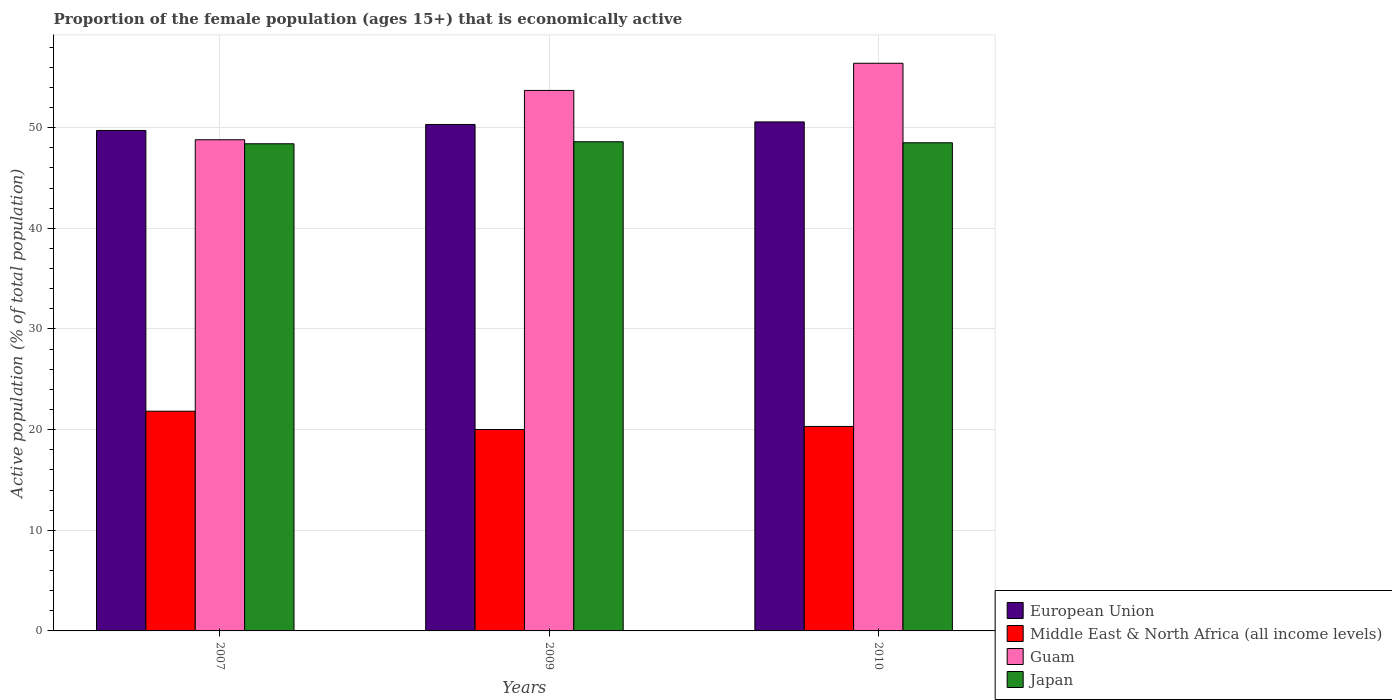How many groups of bars are there?
Ensure brevity in your answer.  3. How many bars are there on the 2nd tick from the left?
Give a very brief answer. 4. In how many cases, is the number of bars for a given year not equal to the number of legend labels?
Your answer should be compact. 0. What is the proportion of the female population that is economically active in Japan in 2007?
Offer a terse response. 48.4. Across all years, what is the maximum proportion of the female population that is economically active in Middle East & North Africa (all income levels)?
Make the answer very short. 21.83. Across all years, what is the minimum proportion of the female population that is economically active in European Union?
Give a very brief answer. 49.72. In which year was the proportion of the female population that is economically active in European Union minimum?
Offer a very short reply. 2007. What is the total proportion of the female population that is economically active in Guam in the graph?
Provide a short and direct response. 158.9. What is the difference between the proportion of the female population that is economically active in Guam in 2007 and that in 2009?
Your answer should be compact. -4.9. What is the difference between the proportion of the female population that is economically active in Guam in 2010 and the proportion of the female population that is economically active in Japan in 2009?
Give a very brief answer. 7.8. What is the average proportion of the female population that is economically active in Guam per year?
Make the answer very short. 52.97. In the year 2010, what is the difference between the proportion of the female population that is economically active in Guam and proportion of the female population that is economically active in Japan?
Give a very brief answer. 7.9. In how many years, is the proportion of the female population that is economically active in Japan greater than 10 %?
Your response must be concise. 3. What is the ratio of the proportion of the female population that is economically active in Japan in 2007 to that in 2009?
Give a very brief answer. 1. Is the proportion of the female population that is economically active in Japan in 2007 less than that in 2010?
Your answer should be very brief. Yes. What is the difference between the highest and the second highest proportion of the female population that is economically active in European Union?
Your response must be concise. 0.25. What is the difference between the highest and the lowest proportion of the female population that is economically active in Middle East & North Africa (all income levels)?
Make the answer very short. 1.82. In how many years, is the proportion of the female population that is economically active in Middle East & North Africa (all income levels) greater than the average proportion of the female population that is economically active in Middle East & North Africa (all income levels) taken over all years?
Offer a terse response. 1. Is the sum of the proportion of the female population that is economically active in Guam in 2009 and 2010 greater than the maximum proportion of the female population that is economically active in European Union across all years?
Ensure brevity in your answer.  Yes. Is it the case that in every year, the sum of the proportion of the female population that is economically active in Middle East & North Africa (all income levels) and proportion of the female population that is economically active in European Union is greater than the sum of proportion of the female population that is economically active in Guam and proportion of the female population that is economically active in Japan?
Provide a short and direct response. No. What does the 4th bar from the left in 2007 represents?
Offer a very short reply. Japan. How many bars are there?
Your answer should be compact. 12. How many years are there in the graph?
Make the answer very short. 3. What is the difference between two consecutive major ticks on the Y-axis?
Ensure brevity in your answer.  10. What is the title of the graph?
Provide a short and direct response. Proportion of the female population (ages 15+) that is economically active. What is the label or title of the X-axis?
Ensure brevity in your answer.  Years. What is the label or title of the Y-axis?
Offer a very short reply. Active population (% of total population). What is the Active population (% of total population) in European Union in 2007?
Give a very brief answer. 49.72. What is the Active population (% of total population) in Middle East & North Africa (all income levels) in 2007?
Offer a terse response. 21.83. What is the Active population (% of total population) in Guam in 2007?
Provide a succinct answer. 48.8. What is the Active population (% of total population) in Japan in 2007?
Your response must be concise. 48.4. What is the Active population (% of total population) of European Union in 2009?
Provide a short and direct response. 50.32. What is the Active population (% of total population) of Middle East & North Africa (all income levels) in 2009?
Ensure brevity in your answer.  20.01. What is the Active population (% of total population) of Guam in 2009?
Ensure brevity in your answer.  53.7. What is the Active population (% of total population) of Japan in 2009?
Offer a terse response. 48.6. What is the Active population (% of total population) in European Union in 2010?
Give a very brief answer. 50.57. What is the Active population (% of total population) of Middle East & North Africa (all income levels) in 2010?
Ensure brevity in your answer.  20.32. What is the Active population (% of total population) of Guam in 2010?
Make the answer very short. 56.4. What is the Active population (% of total population) of Japan in 2010?
Your response must be concise. 48.5. Across all years, what is the maximum Active population (% of total population) of European Union?
Give a very brief answer. 50.57. Across all years, what is the maximum Active population (% of total population) in Middle East & North Africa (all income levels)?
Keep it short and to the point. 21.83. Across all years, what is the maximum Active population (% of total population) in Guam?
Provide a succinct answer. 56.4. Across all years, what is the maximum Active population (% of total population) in Japan?
Ensure brevity in your answer.  48.6. Across all years, what is the minimum Active population (% of total population) in European Union?
Offer a terse response. 49.72. Across all years, what is the minimum Active population (% of total population) in Middle East & North Africa (all income levels)?
Provide a short and direct response. 20.01. Across all years, what is the minimum Active population (% of total population) in Guam?
Give a very brief answer. 48.8. Across all years, what is the minimum Active population (% of total population) of Japan?
Your answer should be very brief. 48.4. What is the total Active population (% of total population) of European Union in the graph?
Make the answer very short. 150.61. What is the total Active population (% of total population) in Middle East & North Africa (all income levels) in the graph?
Provide a short and direct response. 62.16. What is the total Active population (% of total population) of Guam in the graph?
Provide a short and direct response. 158.9. What is the total Active population (% of total population) in Japan in the graph?
Provide a succinct answer. 145.5. What is the difference between the Active population (% of total population) in European Union in 2007 and that in 2009?
Your response must be concise. -0.59. What is the difference between the Active population (% of total population) of Middle East & North Africa (all income levels) in 2007 and that in 2009?
Your answer should be compact. 1.82. What is the difference between the Active population (% of total population) in European Union in 2007 and that in 2010?
Your answer should be very brief. -0.85. What is the difference between the Active population (% of total population) in Middle East & North Africa (all income levels) in 2007 and that in 2010?
Your response must be concise. 1.51. What is the difference between the Active population (% of total population) of Japan in 2007 and that in 2010?
Your answer should be very brief. -0.1. What is the difference between the Active population (% of total population) in European Union in 2009 and that in 2010?
Keep it short and to the point. -0.25. What is the difference between the Active population (% of total population) in Middle East & North Africa (all income levels) in 2009 and that in 2010?
Offer a terse response. -0.3. What is the difference between the Active population (% of total population) in Japan in 2009 and that in 2010?
Your answer should be compact. 0.1. What is the difference between the Active population (% of total population) of European Union in 2007 and the Active population (% of total population) of Middle East & North Africa (all income levels) in 2009?
Offer a very short reply. 29.71. What is the difference between the Active population (% of total population) of European Union in 2007 and the Active population (% of total population) of Guam in 2009?
Offer a very short reply. -3.98. What is the difference between the Active population (% of total population) of European Union in 2007 and the Active population (% of total population) of Japan in 2009?
Make the answer very short. 1.12. What is the difference between the Active population (% of total population) in Middle East & North Africa (all income levels) in 2007 and the Active population (% of total population) in Guam in 2009?
Make the answer very short. -31.87. What is the difference between the Active population (% of total population) of Middle East & North Africa (all income levels) in 2007 and the Active population (% of total population) of Japan in 2009?
Ensure brevity in your answer.  -26.77. What is the difference between the Active population (% of total population) in Guam in 2007 and the Active population (% of total population) in Japan in 2009?
Provide a short and direct response. 0.2. What is the difference between the Active population (% of total population) of European Union in 2007 and the Active population (% of total population) of Middle East & North Africa (all income levels) in 2010?
Provide a succinct answer. 29.41. What is the difference between the Active population (% of total population) in European Union in 2007 and the Active population (% of total population) in Guam in 2010?
Offer a very short reply. -6.68. What is the difference between the Active population (% of total population) in European Union in 2007 and the Active population (% of total population) in Japan in 2010?
Ensure brevity in your answer.  1.22. What is the difference between the Active population (% of total population) in Middle East & North Africa (all income levels) in 2007 and the Active population (% of total population) in Guam in 2010?
Offer a very short reply. -34.57. What is the difference between the Active population (% of total population) in Middle East & North Africa (all income levels) in 2007 and the Active population (% of total population) in Japan in 2010?
Offer a very short reply. -26.67. What is the difference between the Active population (% of total population) of Guam in 2007 and the Active population (% of total population) of Japan in 2010?
Ensure brevity in your answer.  0.3. What is the difference between the Active population (% of total population) of European Union in 2009 and the Active population (% of total population) of Middle East & North Africa (all income levels) in 2010?
Keep it short and to the point. 30. What is the difference between the Active population (% of total population) of European Union in 2009 and the Active population (% of total population) of Guam in 2010?
Give a very brief answer. -6.08. What is the difference between the Active population (% of total population) in European Union in 2009 and the Active population (% of total population) in Japan in 2010?
Your answer should be very brief. 1.82. What is the difference between the Active population (% of total population) in Middle East & North Africa (all income levels) in 2009 and the Active population (% of total population) in Guam in 2010?
Your response must be concise. -36.39. What is the difference between the Active population (% of total population) in Middle East & North Africa (all income levels) in 2009 and the Active population (% of total population) in Japan in 2010?
Offer a terse response. -28.49. What is the average Active population (% of total population) of European Union per year?
Provide a succinct answer. 50.2. What is the average Active population (% of total population) of Middle East & North Africa (all income levels) per year?
Your answer should be very brief. 20.72. What is the average Active population (% of total population) in Guam per year?
Your answer should be very brief. 52.97. What is the average Active population (% of total population) of Japan per year?
Your response must be concise. 48.5. In the year 2007, what is the difference between the Active population (% of total population) of European Union and Active population (% of total population) of Middle East & North Africa (all income levels)?
Keep it short and to the point. 27.89. In the year 2007, what is the difference between the Active population (% of total population) of European Union and Active population (% of total population) of Guam?
Provide a succinct answer. 0.92. In the year 2007, what is the difference between the Active population (% of total population) of European Union and Active population (% of total population) of Japan?
Offer a very short reply. 1.32. In the year 2007, what is the difference between the Active population (% of total population) in Middle East & North Africa (all income levels) and Active population (% of total population) in Guam?
Your answer should be compact. -26.97. In the year 2007, what is the difference between the Active population (% of total population) in Middle East & North Africa (all income levels) and Active population (% of total population) in Japan?
Keep it short and to the point. -26.57. In the year 2007, what is the difference between the Active population (% of total population) in Guam and Active population (% of total population) in Japan?
Provide a succinct answer. 0.4. In the year 2009, what is the difference between the Active population (% of total population) in European Union and Active population (% of total population) in Middle East & North Africa (all income levels)?
Give a very brief answer. 30.31. In the year 2009, what is the difference between the Active population (% of total population) of European Union and Active population (% of total population) of Guam?
Give a very brief answer. -3.38. In the year 2009, what is the difference between the Active population (% of total population) in European Union and Active population (% of total population) in Japan?
Your response must be concise. 1.72. In the year 2009, what is the difference between the Active population (% of total population) in Middle East & North Africa (all income levels) and Active population (% of total population) in Guam?
Offer a very short reply. -33.69. In the year 2009, what is the difference between the Active population (% of total population) of Middle East & North Africa (all income levels) and Active population (% of total population) of Japan?
Offer a terse response. -28.59. In the year 2010, what is the difference between the Active population (% of total population) of European Union and Active population (% of total population) of Middle East & North Africa (all income levels)?
Provide a short and direct response. 30.26. In the year 2010, what is the difference between the Active population (% of total population) of European Union and Active population (% of total population) of Guam?
Provide a short and direct response. -5.83. In the year 2010, what is the difference between the Active population (% of total population) in European Union and Active population (% of total population) in Japan?
Provide a succinct answer. 2.07. In the year 2010, what is the difference between the Active population (% of total population) in Middle East & North Africa (all income levels) and Active population (% of total population) in Guam?
Your answer should be compact. -36.08. In the year 2010, what is the difference between the Active population (% of total population) in Middle East & North Africa (all income levels) and Active population (% of total population) in Japan?
Provide a succinct answer. -28.18. What is the ratio of the Active population (% of total population) of Middle East & North Africa (all income levels) in 2007 to that in 2009?
Make the answer very short. 1.09. What is the ratio of the Active population (% of total population) in Guam in 2007 to that in 2009?
Provide a short and direct response. 0.91. What is the ratio of the Active population (% of total population) in Japan in 2007 to that in 2009?
Offer a terse response. 1. What is the ratio of the Active population (% of total population) of European Union in 2007 to that in 2010?
Your answer should be compact. 0.98. What is the ratio of the Active population (% of total population) of Middle East & North Africa (all income levels) in 2007 to that in 2010?
Offer a terse response. 1.07. What is the ratio of the Active population (% of total population) in Guam in 2007 to that in 2010?
Your answer should be compact. 0.87. What is the ratio of the Active population (% of total population) in Japan in 2007 to that in 2010?
Your answer should be very brief. 1. What is the ratio of the Active population (% of total population) in Guam in 2009 to that in 2010?
Offer a very short reply. 0.95. What is the difference between the highest and the second highest Active population (% of total population) of European Union?
Give a very brief answer. 0.25. What is the difference between the highest and the second highest Active population (% of total population) in Middle East & North Africa (all income levels)?
Make the answer very short. 1.51. What is the difference between the highest and the lowest Active population (% of total population) of European Union?
Your response must be concise. 0.85. What is the difference between the highest and the lowest Active population (% of total population) of Middle East & North Africa (all income levels)?
Make the answer very short. 1.82. What is the difference between the highest and the lowest Active population (% of total population) of Japan?
Offer a terse response. 0.2. 